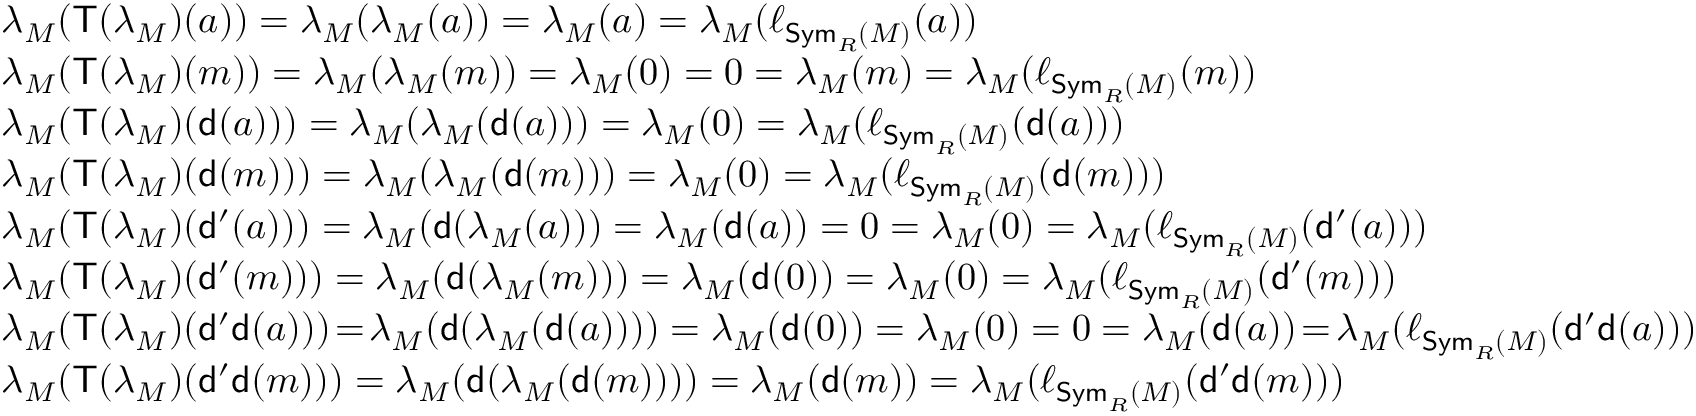Convert formula to latex. <formula><loc_0><loc_0><loc_500><loc_500>\begin{array} { r l } & { \lambda _ { M } ( T ( \lambda _ { M } ) ( a ) ) = \lambda _ { M } ( \lambda _ { M } ( a ) ) = \lambda _ { M } ( a ) = \lambda _ { M } ( \ell _ { S y m _ { R } ( M ) } ( a ) ) } \\ & { \lambda _ { M } ( T ( \lambda _ { M } ) ( m ) ) = \lambda _ { M } ( \lambda _ { M } ( m ) ) = \lambda _ { M } ( 0 ) = 0 = \lambda _ { M } ( m ) = \lambda _ { M } ( \ell _ { S y m _ { R } ( M ) } ( m ) ) } \\ & { \lambda _ { M } ( T ( \lambda _ { M } ) ( d ( a ) ) ) = \lambda _ { M } ( \lambda _ { M } ( d ( a ) ) ) = \lambda _ { M } ( 0 ) = \lambda _ { M } ( \ell _ { S y m _ { R } ( M ) } ( d ( a ) ) ) } \\ & { \lambda _ { M } ( T ( \lambda _ { M } ) ( d ( m ) ) ) = \lambda _ { M } ( \lambda _ { M } ( d ( m ) ) ) = \lambda _ { M } ( 0 ) = \lambda _ { M } ( \ell _ { S y m _ { R } ( M ) } ( d ( m ) ) ) } \\ & { \lambda _ { M } ( T ( \lambda _ { M } ) ( d ^ { \prime } ( a ) ) ) = \lambda _ { M } ( d ( \lambda _ { M } ( a ) ) ) = \lambda _ { M } ( d ( a ) ) = 0 = \lambda _ { M } ( 0 ) = \lambda _ { M } ( \ell _ { S y m _ { R } ( M ) } ( d ^ { \prime } ( a ) ) ) } \\ & { \lambda _ { M } ( T ( \lambda _ { M } ) ( d ^ { \prime } ( m ) ) ) = \lambda _ { M } ( d ( \lambda _ { M } ( m ) ) ) = \lambda _ { M } ( d ( 0 ) ) = \lambda _ { M } ( 0 ) = \lambda _ { M } ( \ell _ { S y m _ { R } ( M ) } ( d ^ { \prime } ( m ) ) ) } \\ & { \lambda _ { M } ( T ( \lambda _ { M } ) ( d ^ { \prime } d ( a ) ) ) \, = \, \lambda _ { M } ( d ( \lambda _ { M } ( d ( a ) ) ) ) = \lambda _ { M } ( d ( 0 ) ) = \lambda _ { M } ( 0 ) = 0 = \lambda _ { M } ( d ( a ) ) \, = \, \lambda _ { M } ( \ell _ { S y m _ { R } ( M ) } ( d ^ { \prime } d ( a ) ) ) } \\ & { \lambda _ { M } ( T ( \lambda _ { M } ) ( d ^ { \prime } d ( m ) ) ) = \lambda _ { M } ( d ( \lambda _ { M } ( d ( m ) ) ) ) = \lambda _ { M } ( d ( m ) ) = \lambda _ { M } ( \ell _ { S y m _ { R } ( M ) } ( d ^ { \prime } d ( m ) ) ) } \end{array}</formula> 